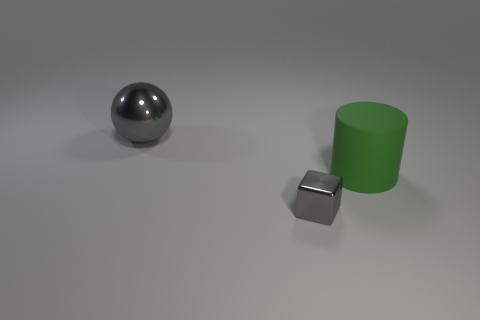Add 1 big gray shiny spheres. How many objects exist? 4 Subtract all cylinders. How many objects are left? 2 Subtract 0 yellow spheres. How many objects are left? 3 Subtract all big brown balls. Subtract all large gray balls. How many objects are left? 2 Add 2 large shiny spheres. How many large shiny spheres are left? 3 Add 2 blue matte cylinders. How many blue matte cylinders exist? 2 